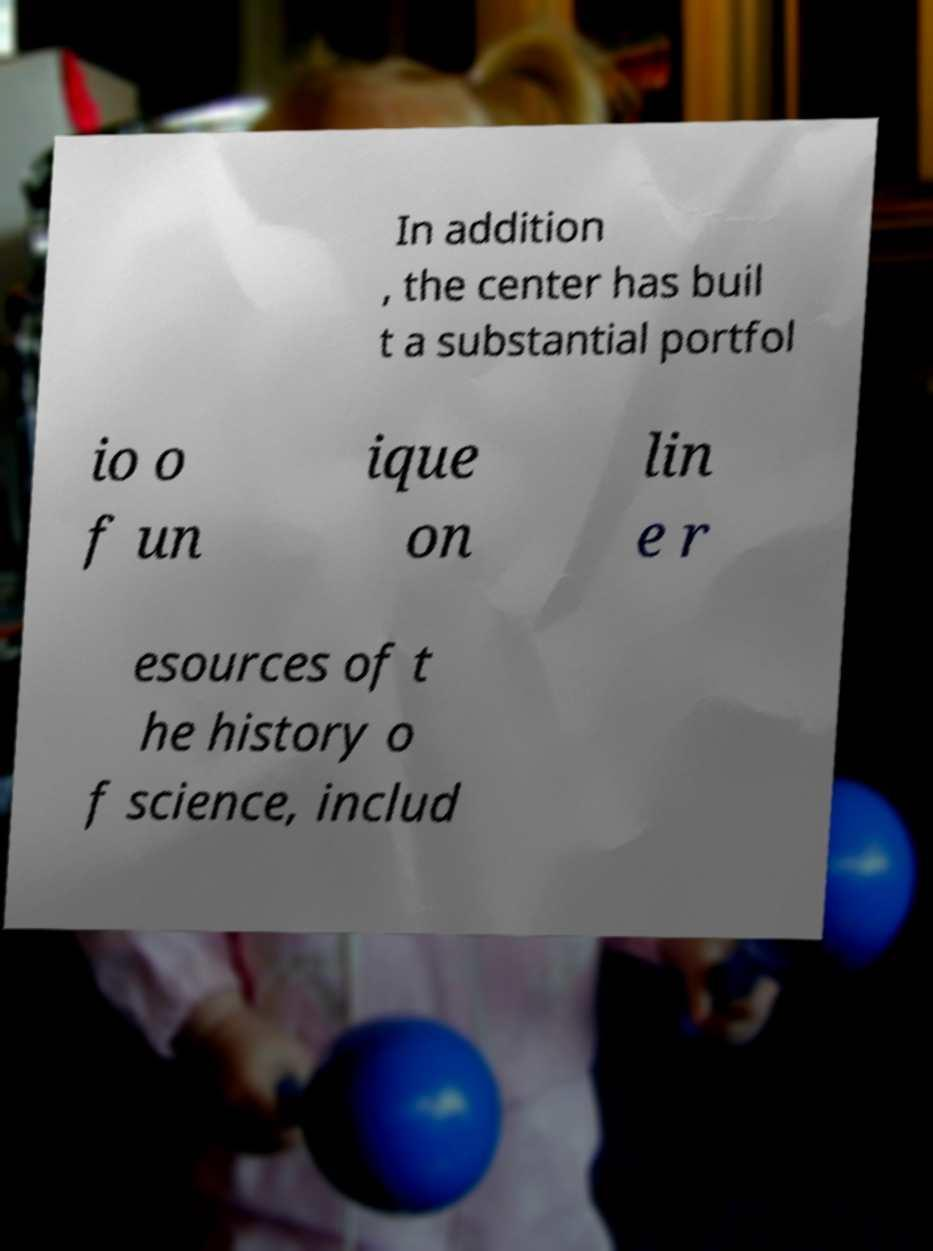There's text embedded in this image that I need extracted. Can you transcribe it verbatim? In addition , the center has buil t a substantial portfol io o f un ique on lin e r esources of t he history o f science, includ 